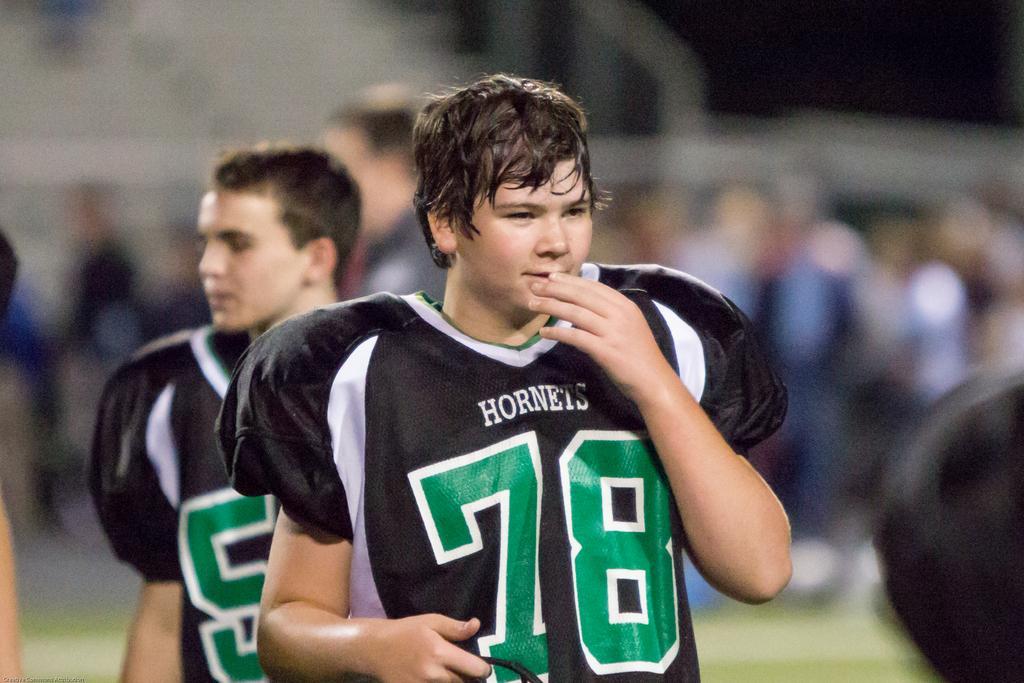In one or two sentences, can you explain what this image depicts? In the foreground of this image, there are men and the background image is blur. 